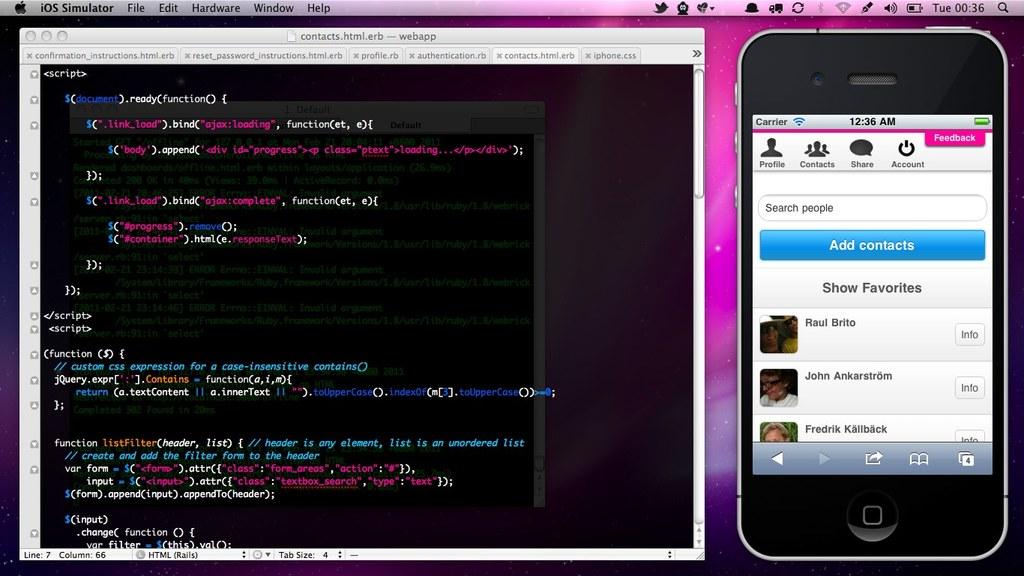They are chatting?
Keep it short and to the point. No. 